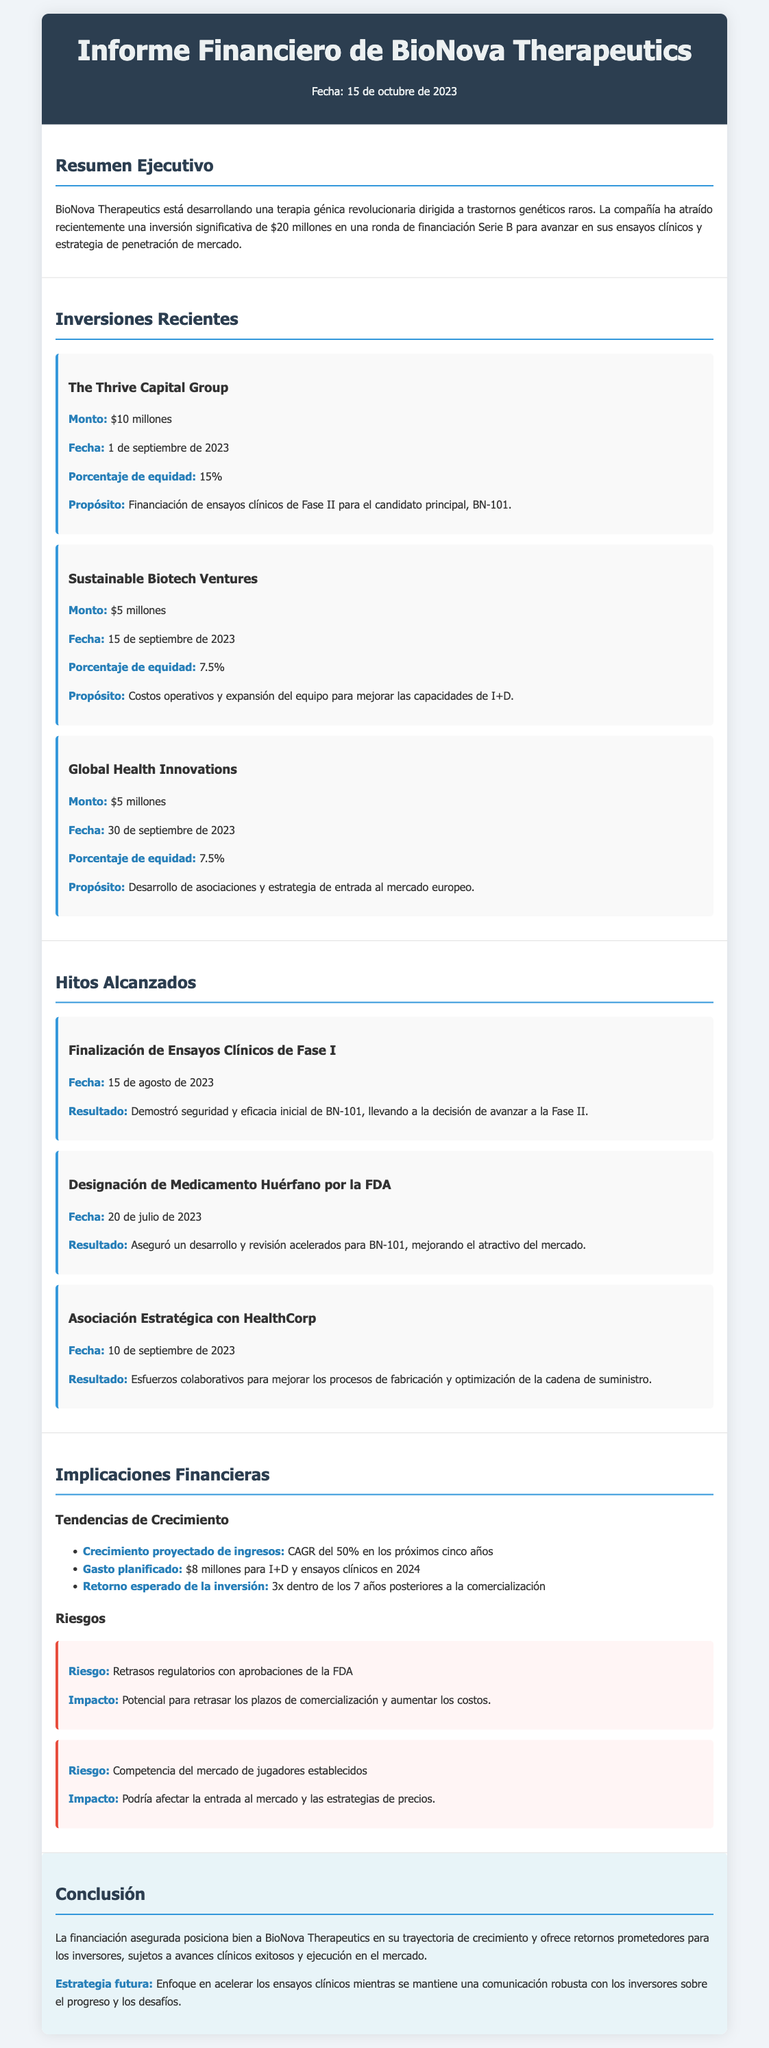¿Cuál es el monto total de la inversión asegurada en la ronda Serie B? El monto total de la inversión asegurada es de $20 millones, como se menciona en el resumen ejecutivo.
Answer: $20 millones ¿Cuál es el porcentaje de equidad ofrecido a The Thrive Capital Group? El porcentaje de equidad ofrecido a The Thrive Capital Group es del 15%, según la sección de inversiones recientes.
Answer: 15% ¿Cuál es la fecha de finalización de los ensayos clínicos de Fase I? La fecha de finalización de los ensayos clínicos de Fase I es el 15 de agosto de 2023, indicado en los hitos alcanzados.
Answer: 15 de agosto de 2023 ¿Qué resultado demuestra la designación de medicamento huérfano por la FDA? La designación de medicamento huérfano asegura un desarrollo y revisión acelerados para BN-101, como se menciona en los hitos alcanzados.
Answer: Desarrollo y revisión acelerados ¿Cuál es el crecimiento proyectado de ingresos en los próximos cinco años? El crecimiento proyectado de ingresos es un CAGR del 50% en los próximos cinco años, según la sección de implicaciones financieras.
Answer: CAGR del 50% ¿Qué riesgo se asocia con los retrasos regulatorios? El riesgo asociado con los retrasos regulatorios implica el potencial de retrasar los plazos de comercialización y aumentar los costos.
Answer: Retrasos de comercialización ¿Cuál es la estrategia futura mencionada en la conclusión? La estrategia futura se enfoca en acelerar los ensayos clínicos y mantener una comunicación robusta con los inversores.
Answer: Acelerar ensayos clínicos ¿Qué propósito tiene la inversión de Sustainable Biotech Ventures? El propósito de la inversión de Sustainable Biotech Ventures es cubrir costos operativos y expandir el equipo para mejorar I+D.
Answer: Costos operativos y expansión del equipo 